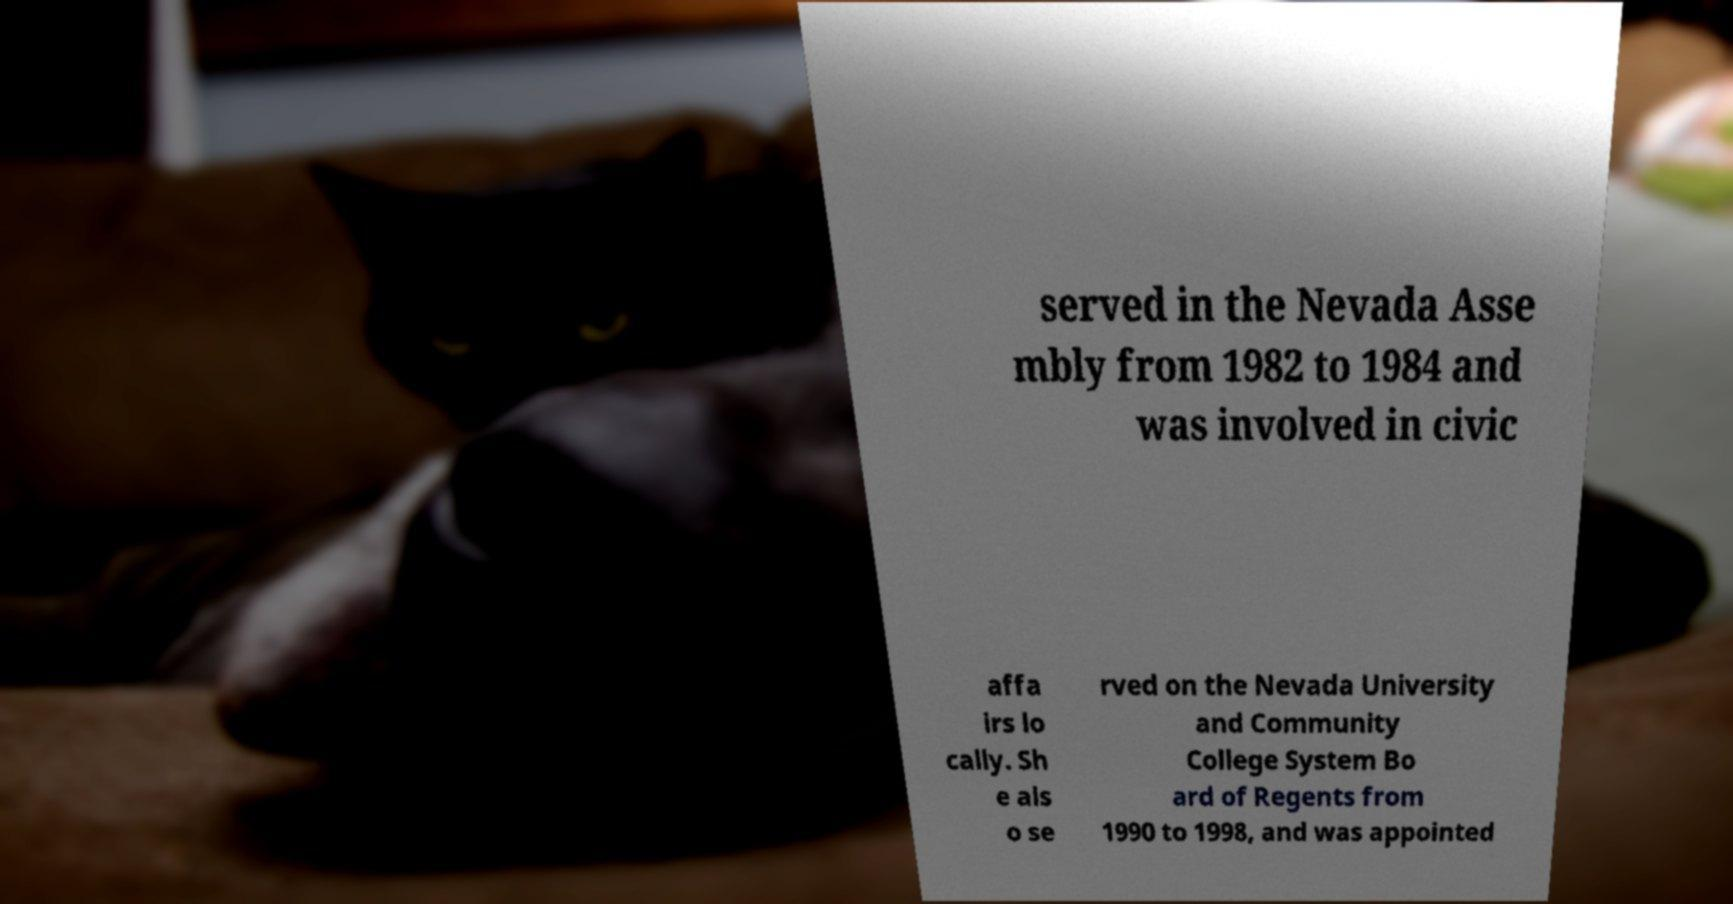Please read and relay the text visible in this image. What does it say? served in the Nevada Asse mbly from 1982 to 1984 and was involved in civic affa irs lo cally. Sh e als o se rved on the Nevada University and Community College System Bo ard of Regents from 1990 to 1998, and was appointed 